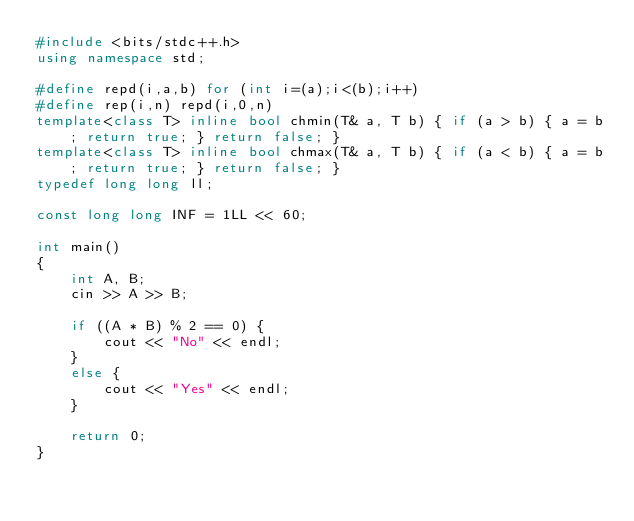<code> <loc_0><loc_0><loc_500><loc_500><_C++_>#include <bits/stdc++.h>
using namespace std;

#define repd(i,a,b) for (int i=(a);i<(b);i++)
#define rep(i,n) repd(i,0,n)
template<class T> inline bool chmin(T& a, T b) { if (a > b) { a = b; return true; } return false; }
template<class T> inline bool chmax(T& a, T b) { if (a < b) { a = b; return true; } return false; }
typedef long long ll;

const long long INF = 1LL << 60;

int main()
{
    int A, B;
    cin >> A >> B;

    if ((A * B) % 2 == 0) {
        cout << "No" << endl;
    }
    else {
        cout << "Yes" << endl;
    }

    return 0;
}</code> 